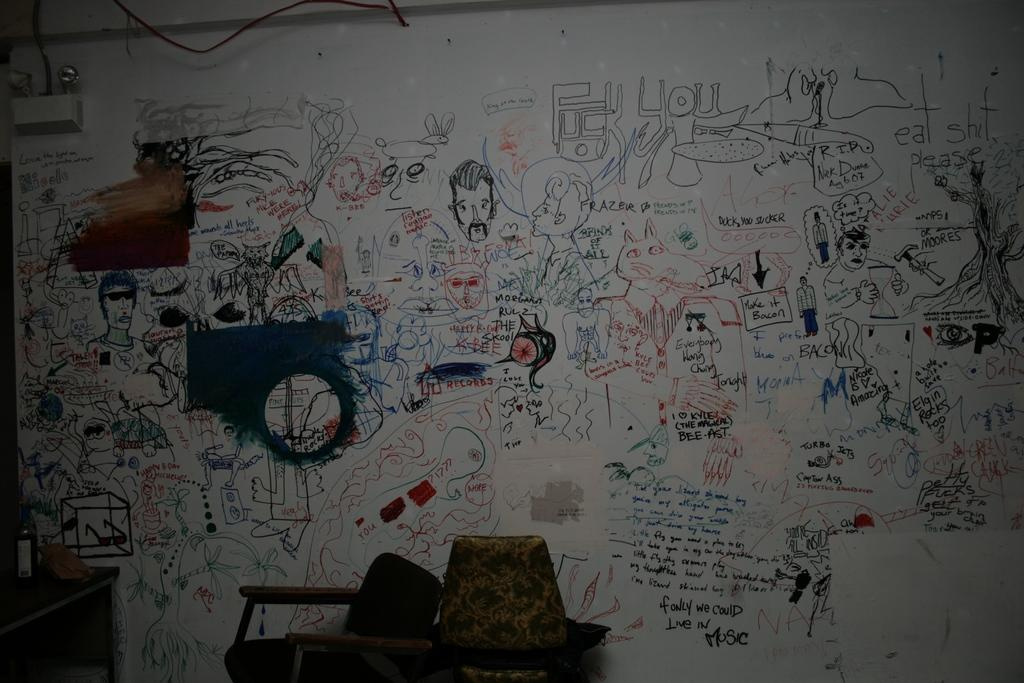What is the main object in the image? There is a whiteboard in the image. What is on the whiteboard? There is writing on the whiteboard. What else can be seen in the image besides the whiteboard? There are pictures in the image. Can you describe the "things" mentioned in the facts? Unfortunately, the facts do not specify what these "things" are, so we cannot describe them. What is the profit margin of the company mentioned on the whiteboard? There is no mention of a company or profit margin on the whiteboard, so we cannot determine the profit margin. --- Facts: 1. There is a person in the image. 2. The person is wearing a hat. 3. The person is holding a book. 4. There is a table in the image. 5. The table has a lamp on it. Absurd Topics: ocean, dance, animal Conversation: Who is in the image? There is a person in the image. What is the person wearing? The person is wearing a hat. What is the person holding? The person is holding a book. What is on the table in the image? There is a lamp on the table in the image. Reasoning: Let's think step by step in order to produce the conversation. We start by identifying the main subject in the image, which is the person. Then, we describe the person's attire, mentioning the hat. Next, we focus on the object the person is holding, which is a book. Finally, we mention the presence of a table and its contents, which include a lamp. Absurd Question/Answer: Can you describe the ocean waves in the image? There is no ocean or waves present in the image; it features a person wearing a hat, holding a book, and standing near a table with a lamp. --- Facts: 1. There is a car in the image. 2. The car is red. 3. The car has four wheels. 4. There is a road in the image. 5. The road is paved. Absurd Topics: bird, rain, mountain Conversation: What is the main subject of the image? There is a car in the image. What color is the car? The car is red. How many wheels does the car have? The car has four wheels. What is the surface of the road in the image? The road is paved. Reasoning: Let's think step by step in order to produce the conversation. We start by identifying the main subject in the image, which is the car. Then, we describe the car's color, mentioning that it is red. Next, we focus on the car's wheels, stating that it has four. Finally, we mention 